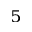<formula> <loc_0><loc_0><loc_500><loc_500>^ { 5 }</formula> 